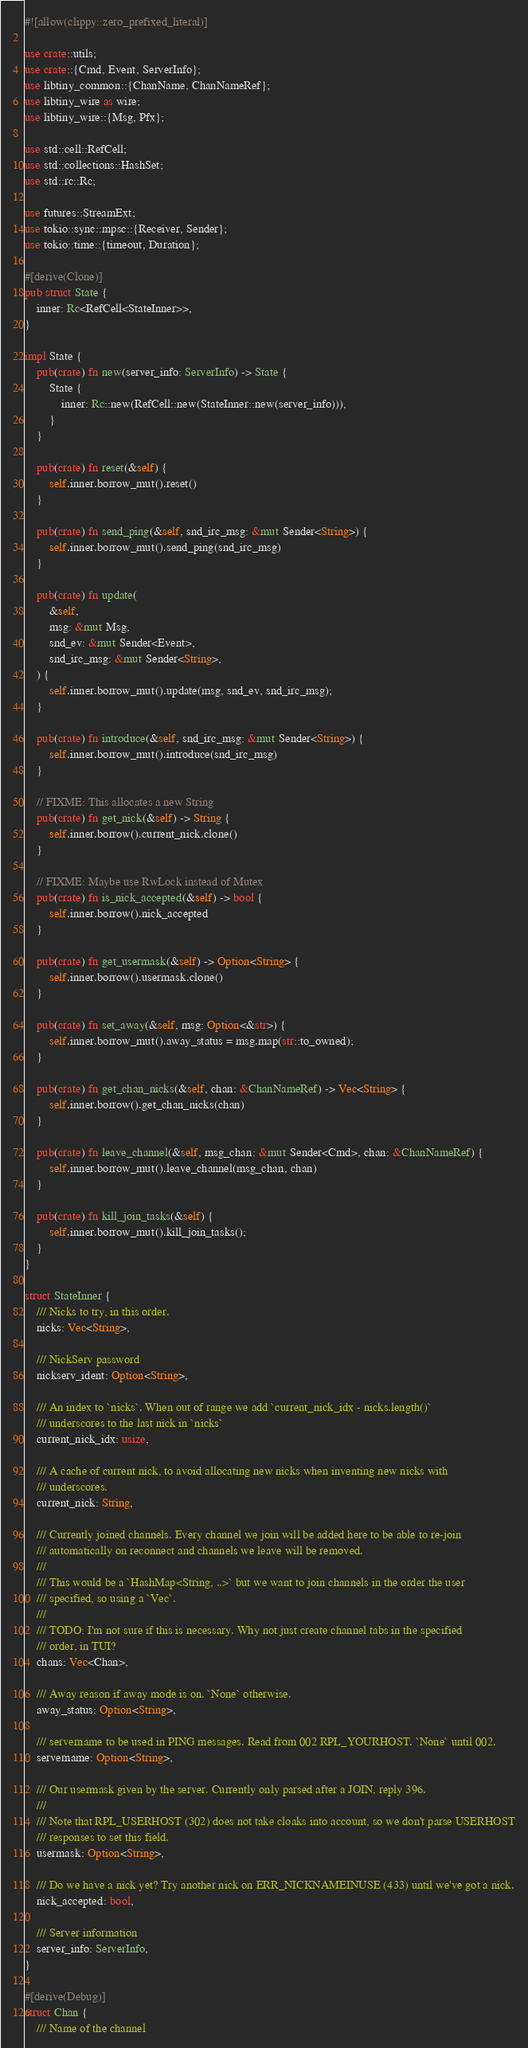<code> <loc_0><loc_0><loc_500><loc_500><_Rust_>#![allow(clippy::zero_prefixed_literal)]

use crate::utils;
use crate::{Cmd, Event, ServerInfo};
use libtiny_common::{ChanName, ChanNameRef};
use libtiny_wire as wire;
use libtiny_wire::{Msg, Pfx};

use std::cell::RefCell;
use std::collections::HashSet;
use std::rc::Rc;

use futures::StreamExt;
use tokio::sync::mpsc::{Receiver, Sender};
use tokio::time::{timeout, Duration};

#[derive(Clone)]
pub struct State {
    inner: Rc<RefCell<StateInner>>,
}

impl State {
    pub(crate) fn new(server_info: ServerInfo) -> State {
        State {
            inner: Rc::new(RefCell::new(StateInner::new(server_info))),
        }
    }

    pub(crate) fn reset(&self) {
        self.inner.borrow_mut().reset()
    }

    pub(crate) fn send_ping(&self, snd_irc_msg: &mut Sender<String>) {
        self.inner.borrow_mut().send_ping(snd_irc_msg)
    }

    pub(crate) fn update(
        &self,
        msg: &mut Msg,
        snd_ev: &mut Sender<Event>,
        snd_irc_msg: &mut Sender<String>,
    ) {
        self.inner.borrow_mut().update(msg, snd_ev, snd_irc_msg);
    }

    pub(crate) fn introduce(&self, snd_irc_msg: &mut Sender<String>) {
        self.inner.borrow_mut().introduce(snd_irc_msg)
    }

    // FIXME: This allocates a new String
    pub(crate) fn get_nick(&self) -> String {
        self.inner.borrow().current_nick.clone()
    }

    // FIXME: Maybe use RwLock instead of Mutex
    pub(crate) fn is_nick_accepted(&self) -> bool {
        self.inner.borrow().nick_accepted
    }

    pub(crate) fn get_usermask(&self) -> Option<String> {
        self.inner.borrow().usermask.clone()
    }

    pub(crate) fn set_away(&self, msg: Option<&str>) {
        self.inner.borrow_mut().away_status = msg.map(str::to_owned);
    }

    pub(crate) fn get_chan_nicks(&self, chan: &ChanNameRef) -> Vec<String> {
        self.inner.borrow().get_chan_nicks(chan)
    }

    pub(crate) fn leave_channel(&self, msg_chan: &mut Sender<Cmd>, chan: &ChanNameRef) {
        self.inner.borrow_mut().leave_channel(msg_chan, chan)
    }

    pub(crate) fn kill_join_tasks(&self) {
        self.inner.borrow_mut().kill_join_tasks();
    }
}

struct StateInner {
    /// Nicks to try, in this order.
    nicks: Vec<String>,

    /// NickServ password
    nickserv_ident: Option<String>,

    /// An index to `nicks`. When out of range we add `current_nick_idx - nicks.length()`
    /// underscores to the last nick in `nicks`
    current_nick_idx: usize,

    /// A cache of current nick, to avoid allocating new nicks when inventing new nicks with
    /// underscores.
    current_nick: String,

    /// Currently joined channels. Every channel we join will be added here to be able to re-join
    /// automatically on reconnect and channels we leave will be removed.
    ///
    /// This would be a `HashMap<String, ..>` but we want to join channels in the order the user
    /// specified, so using a `Vec`.
    ///
    /// TODO: I'm not sure if this is necessary. Why not just create channel tabs in the specified
    /// order, in TUI?
    chans: Vec<Chan>,

    /// Away reason if away mode is on. `None` otherwise.
    away_status: Option<String>,

    /// servername to be used in PING messages. Read from 002 RPL_YOURHOST. `None` until 002.
    servername: Option<String>,

    /// Our usermask given by the server. Currently only parsed after a JOIN, reply 396.
    ///
    /// Note that RPL_USERHOST (302) does not take cloaks into account, so we don't parse USERHOST
    /// responses to set this field.
    usermask: Option<String>,

    /// Do we have a nick yet? Try another nick on ERR_NICKNAMEINUSE (433) until we've got a nick.
    nick_accepted: bool,

    /// Server information
    server_info: ServerInfo,
}

#[derive(Debug)]
struct Chan {
    /// Name of the channel</code> 